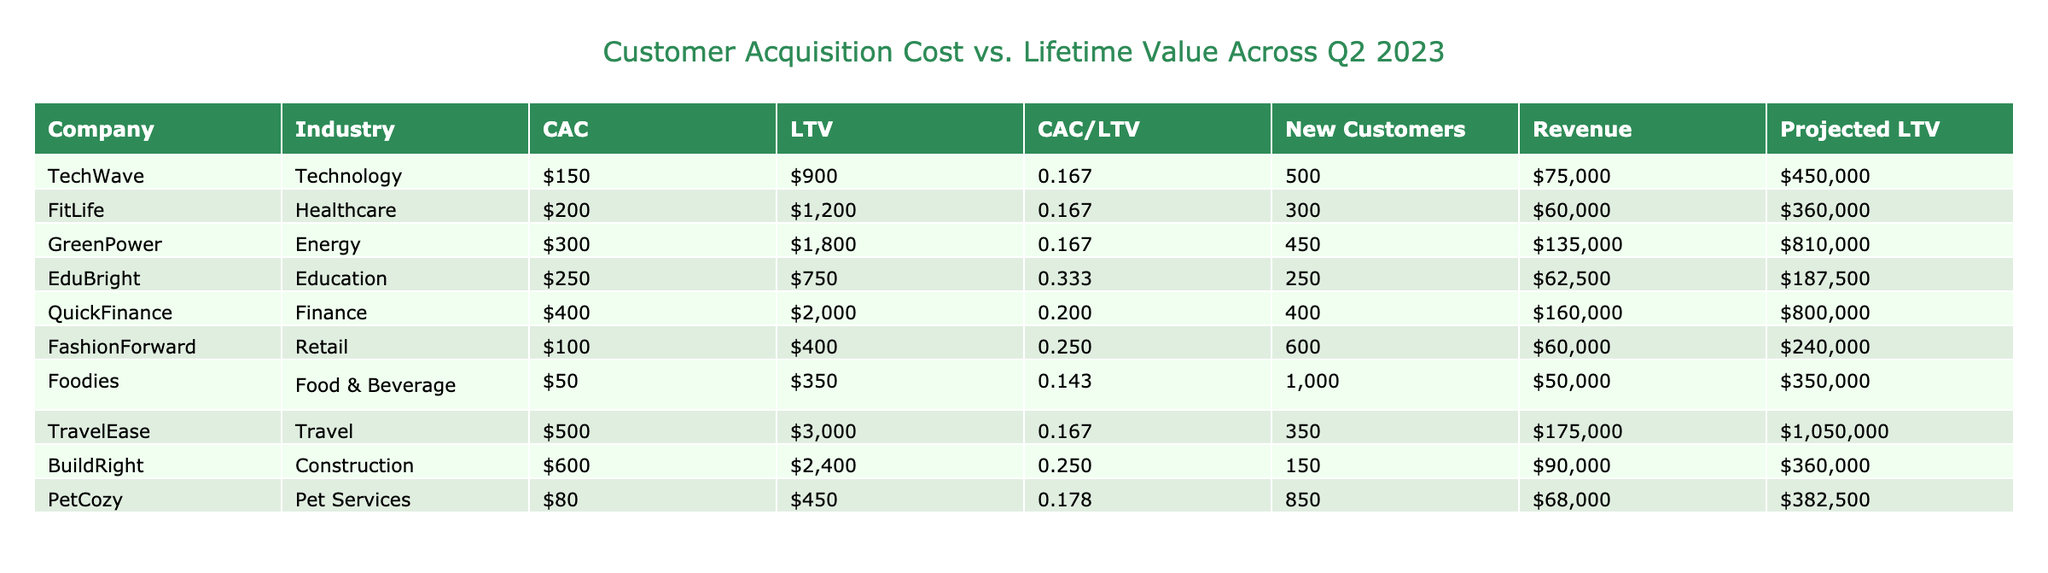What is the Customer Acquisition Cost (CAC) for TravelEase? The table shows that the CAC for TravelEase is listed under the 'Customer Acquisition Cost (CAC)' column. By directly referring to the table, we see that it is $500.
Answer: 500 Which company has the highest Customer Lifetime Value (LTV)? In the table, the LTV values are compared across all companies. The highest value of $3000 corresponds to TravelEase.
Answer: 3000 What is the total number of new customers acquired by TechWave and QuickFinance combined? Adding the 'Q2 2023 New Customers' for TechWave (500) and QuickFinance (400) gives us a total of 500 + 400 = 900 new customers.
Answer: 900 What is the average CAC for the companies in the education and healthcare industries? The CAC for EduBright (250) and FitLife (200) is averaged. The sum is 250 + 200 = 450, and dividing by the number of companies (2) gives 450 / 2 = 225.
Answer: 225 Is the CAC to LTV ratio for PetCozy greater than 0.2? Looking at PetCozy's row, the CAC to LTV ratio is 0.178. Since 0.178 is less than 0.2, the answer is no.
Answer: No What percentage of the total projected LTV is accounted for by QuickFinance? First, calculate total projected LTV: TechWave (450000), FitLife (360000), GreenPower (810000), EduBright (187500), QuickFinance (800000), FashionForward (240000), Foodies (350000), TravelEase (1050000), BuildRight (360000), PetCozy (382500). The total is 450000 + 360000 + 810000 + 187500 + 800000 + 240000 + 350000 + 1050000 + 360000 + 382500 = 4100000. QuickFinance's projected LTV is 800000, thus the percentage is (800000 / 4100000) * 100 ≈ 19.5%.
Answer: 19.5 How many companies have a CAC to LTV ratio of less than or equal to 0.2? We identify the companies with CAC to LTV ratios less than or equal to 0.2: TechWave (0.167), FitLife (0.167), QuickFinance (0.200), Foodies (0.143), TravelEase (0.167). This gives us a total of 5 companies.
Answer: 5 What is the difference between the highest and lowest New Customers acquired? The highest is Foodies with 1000 new customers and the lowest is BuildRight with 150 new customers. Therefore, the difference is 1000 - 150 = 850.
Answer: 850 Which industry has the lowest Customer Acquisition Cost? By comparing the CAC values in the table, we find Food & Beverage has the lowest CAC at $50.
Answer: 50 